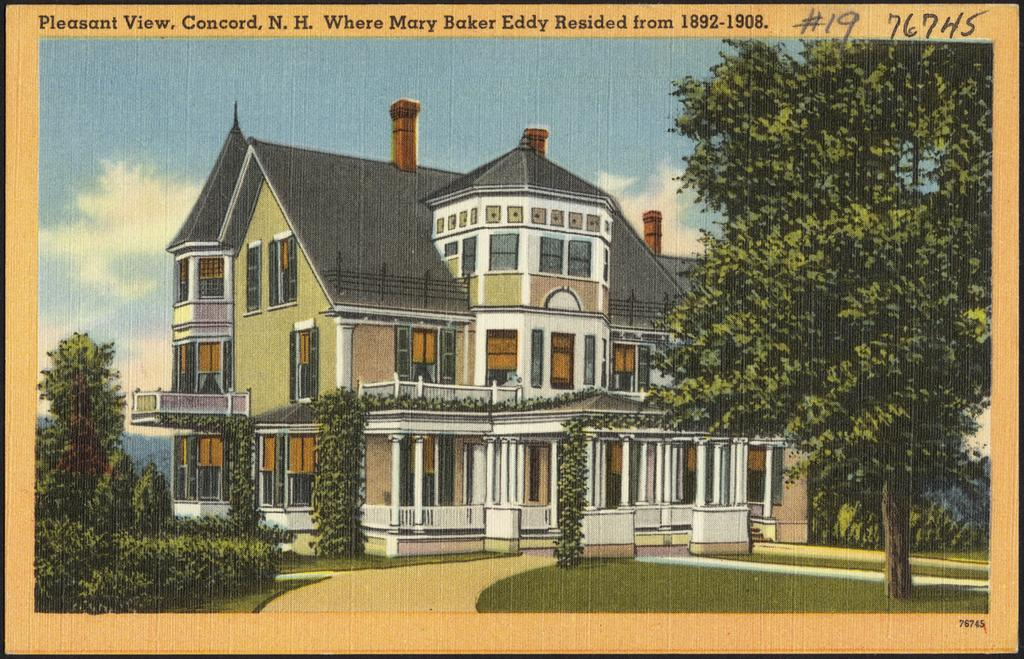What type of image is being described? The image is a poster. What natural elements can be seen in the poster? There are trees, grass, and plants visible in the poster. Are there any man-made structures in the poster? Yes, there is a building in the poster. What part of the natural environment is visible in the poster? The sky is visible in the poster. Is there any text or writing on the poster? Yes, there is something written on the poster. How many beams are supporting the skate in the poster? There is no skate or beam present in the poster. What number is written on the poster? There is no specific number mentioned in the provided facts; we only know that there is something written on the poster. 